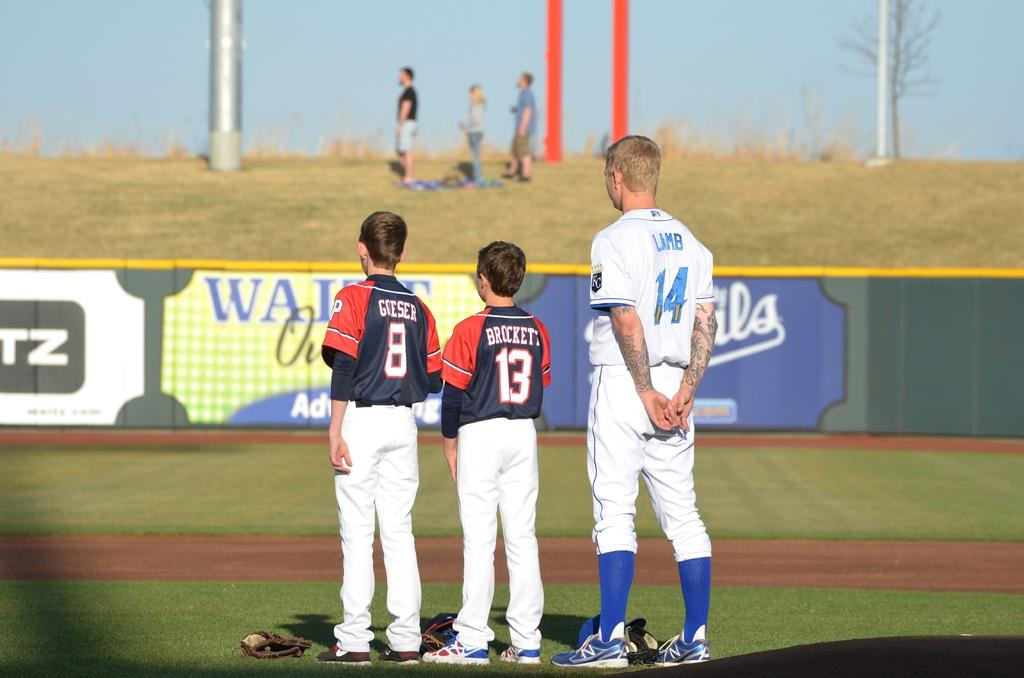<image>
Give a short and clear explanation of the subsequent image. three baseball players on a field the one in white wearing the number 14 